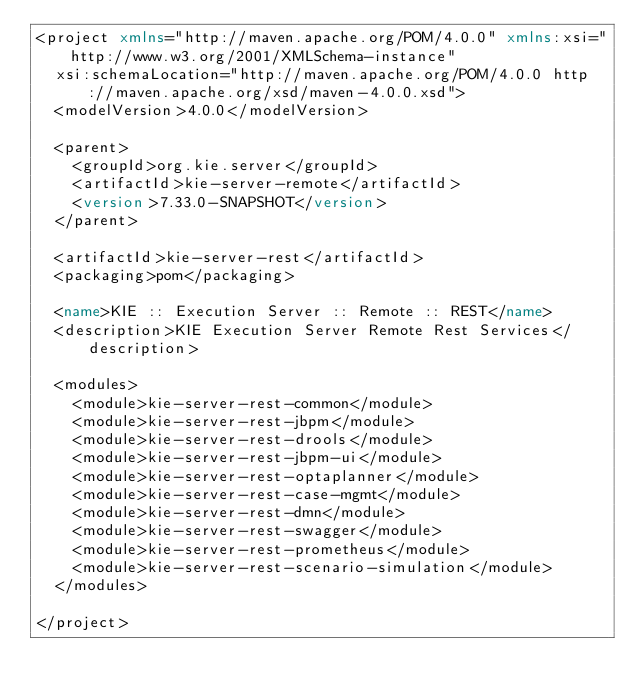Convert code to text. <code><loc_0><loc_0><loc_500><loc_500><_XML_><project xmlns="http://maven.apache.org/POM/4.0.0" xmlns:xsi="http://www.w3.org/2001/XMLSchema-instance"
  xsi:schemaLocation="http://maven.apache.org/POM/4.0.0 http://maven.apache.org/xsd/maven-4.0.0.xsd">
  <modelVersion>4.0.0</modelVersion>

  <parent>
    <groupId>org.kie.server</groupId>
    <artifactId>kie-server-remote</artifactId>
    <version>7.33.0-SNAPSHOT</version>
  </parent>

  <artifactId>kie-server-rest</artifactId>
  <packaging>pom</packaging>

  <name>KIE :: Execution Server :: Remote :: REST</name>
  <description>KIE Execution Server Remote Rest Services</description>

  <modules>
    <module>kie-server-rest-common</module>
    <module>kie-server-rest-jbpm</module>
    <module>kie-server-rest-drools</module>
    <module>kie-server-rest-jbpm-ui</module>
    <module>kie-server-rest-optaplanner</module>
    <module>kie-server-rest-case-mgmt</module>
    <module>kie-server-rest-dmn</module>
    <module>kie-server-rest-swagger</module>
    <module>kie-server-rest-prometheus</module>
    <module>kie-server-rest-scenario-simulation</module>
  </modules>

</project>
</code> 